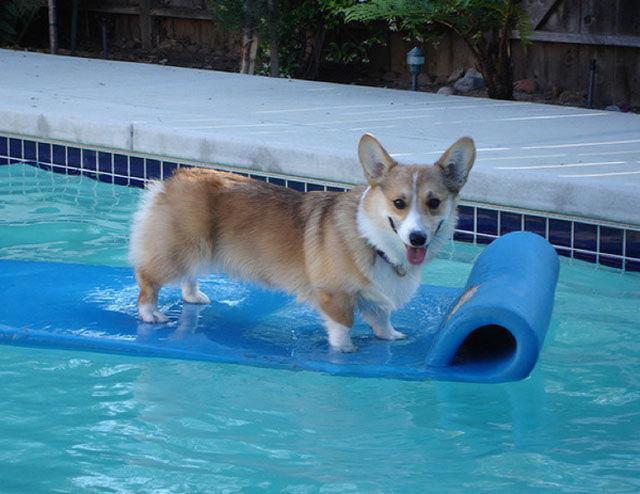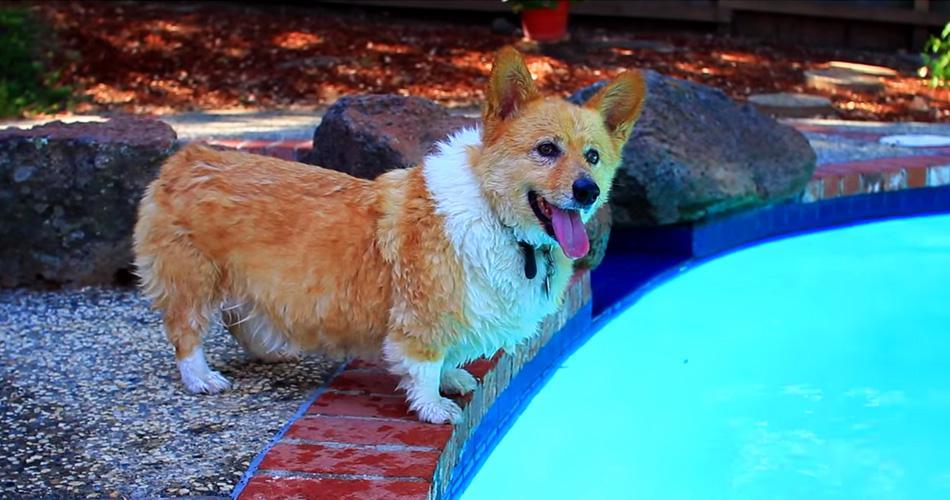The first image is the image on the left, the second image is the image on the right. Examine the images to the left and right. Is the description "In one image there is a corgi riding on a raft in a pool and the other shows at least one dog in a kiddie pool." accurate? Answer yes or no. No. 